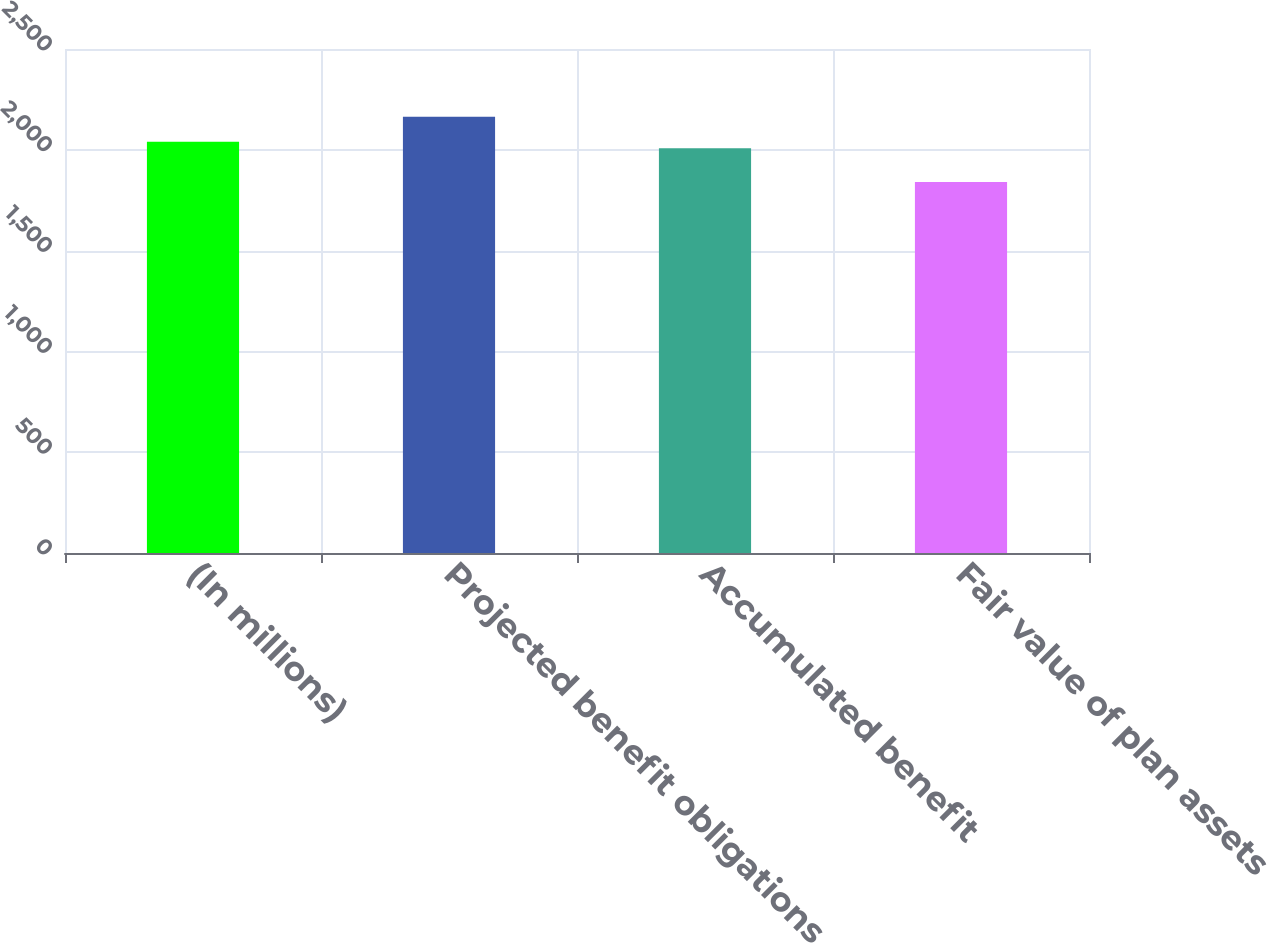<chart> <loc_0><loc_0><loc_500><loc_500><bar_chart><fcel>(In millions)<fcel>Projected benefit obligations<fcel>Accumulated benefit<fcel>Fair value of plan assets<nl><fcel>2040.4<fcel>2164<fcel>2008<fcel>1840<nl></chart> 